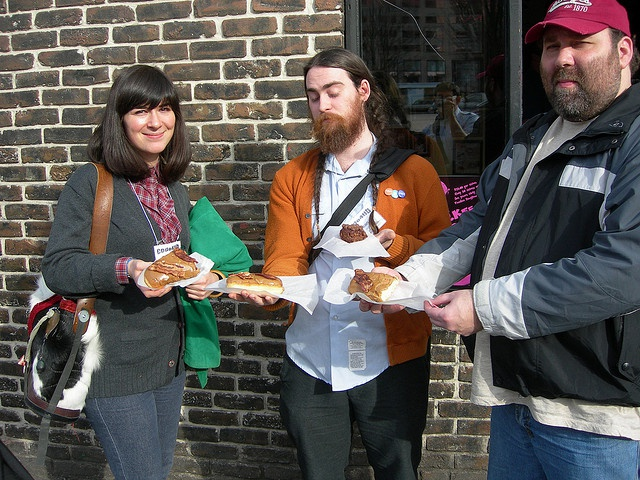Describe the objects in this image and their specific colors. I can see people in darkgreen, black, gray, navy, and lightgray tones, people in darkgreen, black, white, maroon, and red tones, people in darkgreen, gray, black, purple, and teal tones, handbag in darkgreen, black, gray, lightgray, and maroon tones, and people in darkgreen, black, gray, and darkblue tones in this image. 